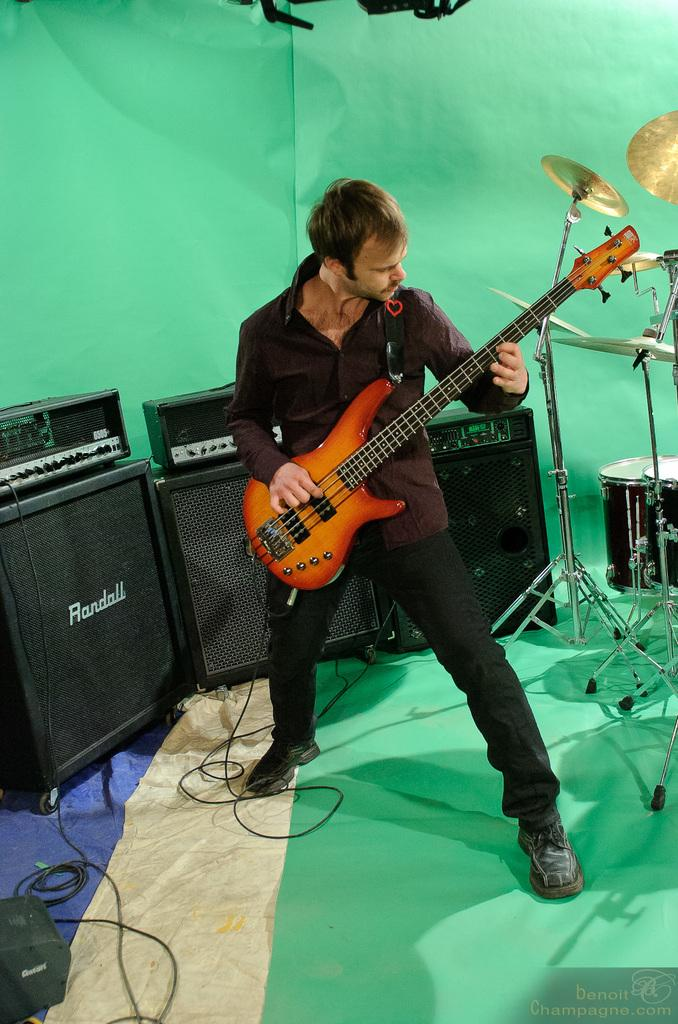What is the man in the image doing? The man is playing the guitar. What is the man holding in the image? The man is holding a guitar. What can be seen in the background of the image? There are speakers, electronic drums, and a green mat in the background of the image. What type of plants can be seen growing on the calendar in the image? There is no calendar or plants present in the image. 